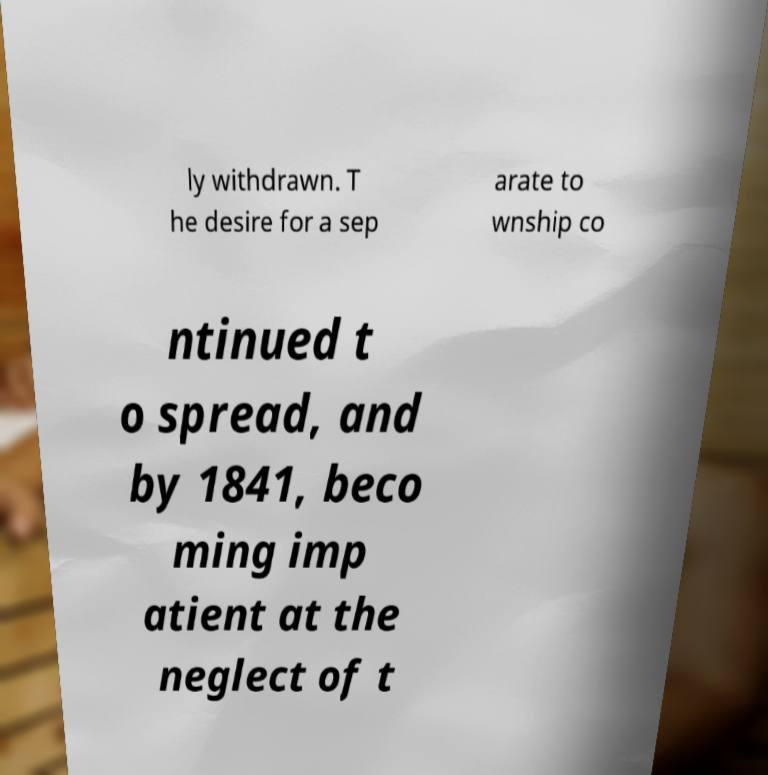Please identify and transcribe the text found in this image. ly withdrawn. T he desire for a sep arate to wnship co ntinued t o spread, and by 1841, beco ming imp atient at the neglect of t 